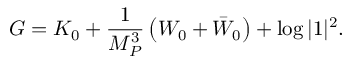Convert formula to latex. <formula><loc_0><loc_0><loc_500><loc_500>G = K _ { 0 } + { \frac { 1 } { M _ { P } ^ { 3 } } } \left ( W _ { 0 } + \bar { W } _ { 0 } \right ) + \log | 1 | ^ { 2 } .</formula> 